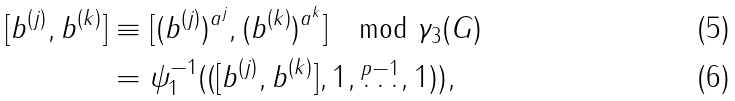Convert formula to latex. <formula><loc_0><loc_0><loc_500><loc_500>[ b ^ { ( j ) } , b ^ { ( k ) } ] & \equiv [ ( b ^ { ( j ) } ) ^ { a ^ { j } } , ( b ^ { ( k ) } ) ^ { a ^ { k } } ] \quad \text {mod } \gamma _ { 3 } ( G ) \\ & = \psi _ { 1 } ^ { - 1 } ( ( [ b ^ { ( j ) } , b ^ { ( k ) } ] , 1 , \overset { p - 1 } \dots , 1 ) ) ,</formula> 